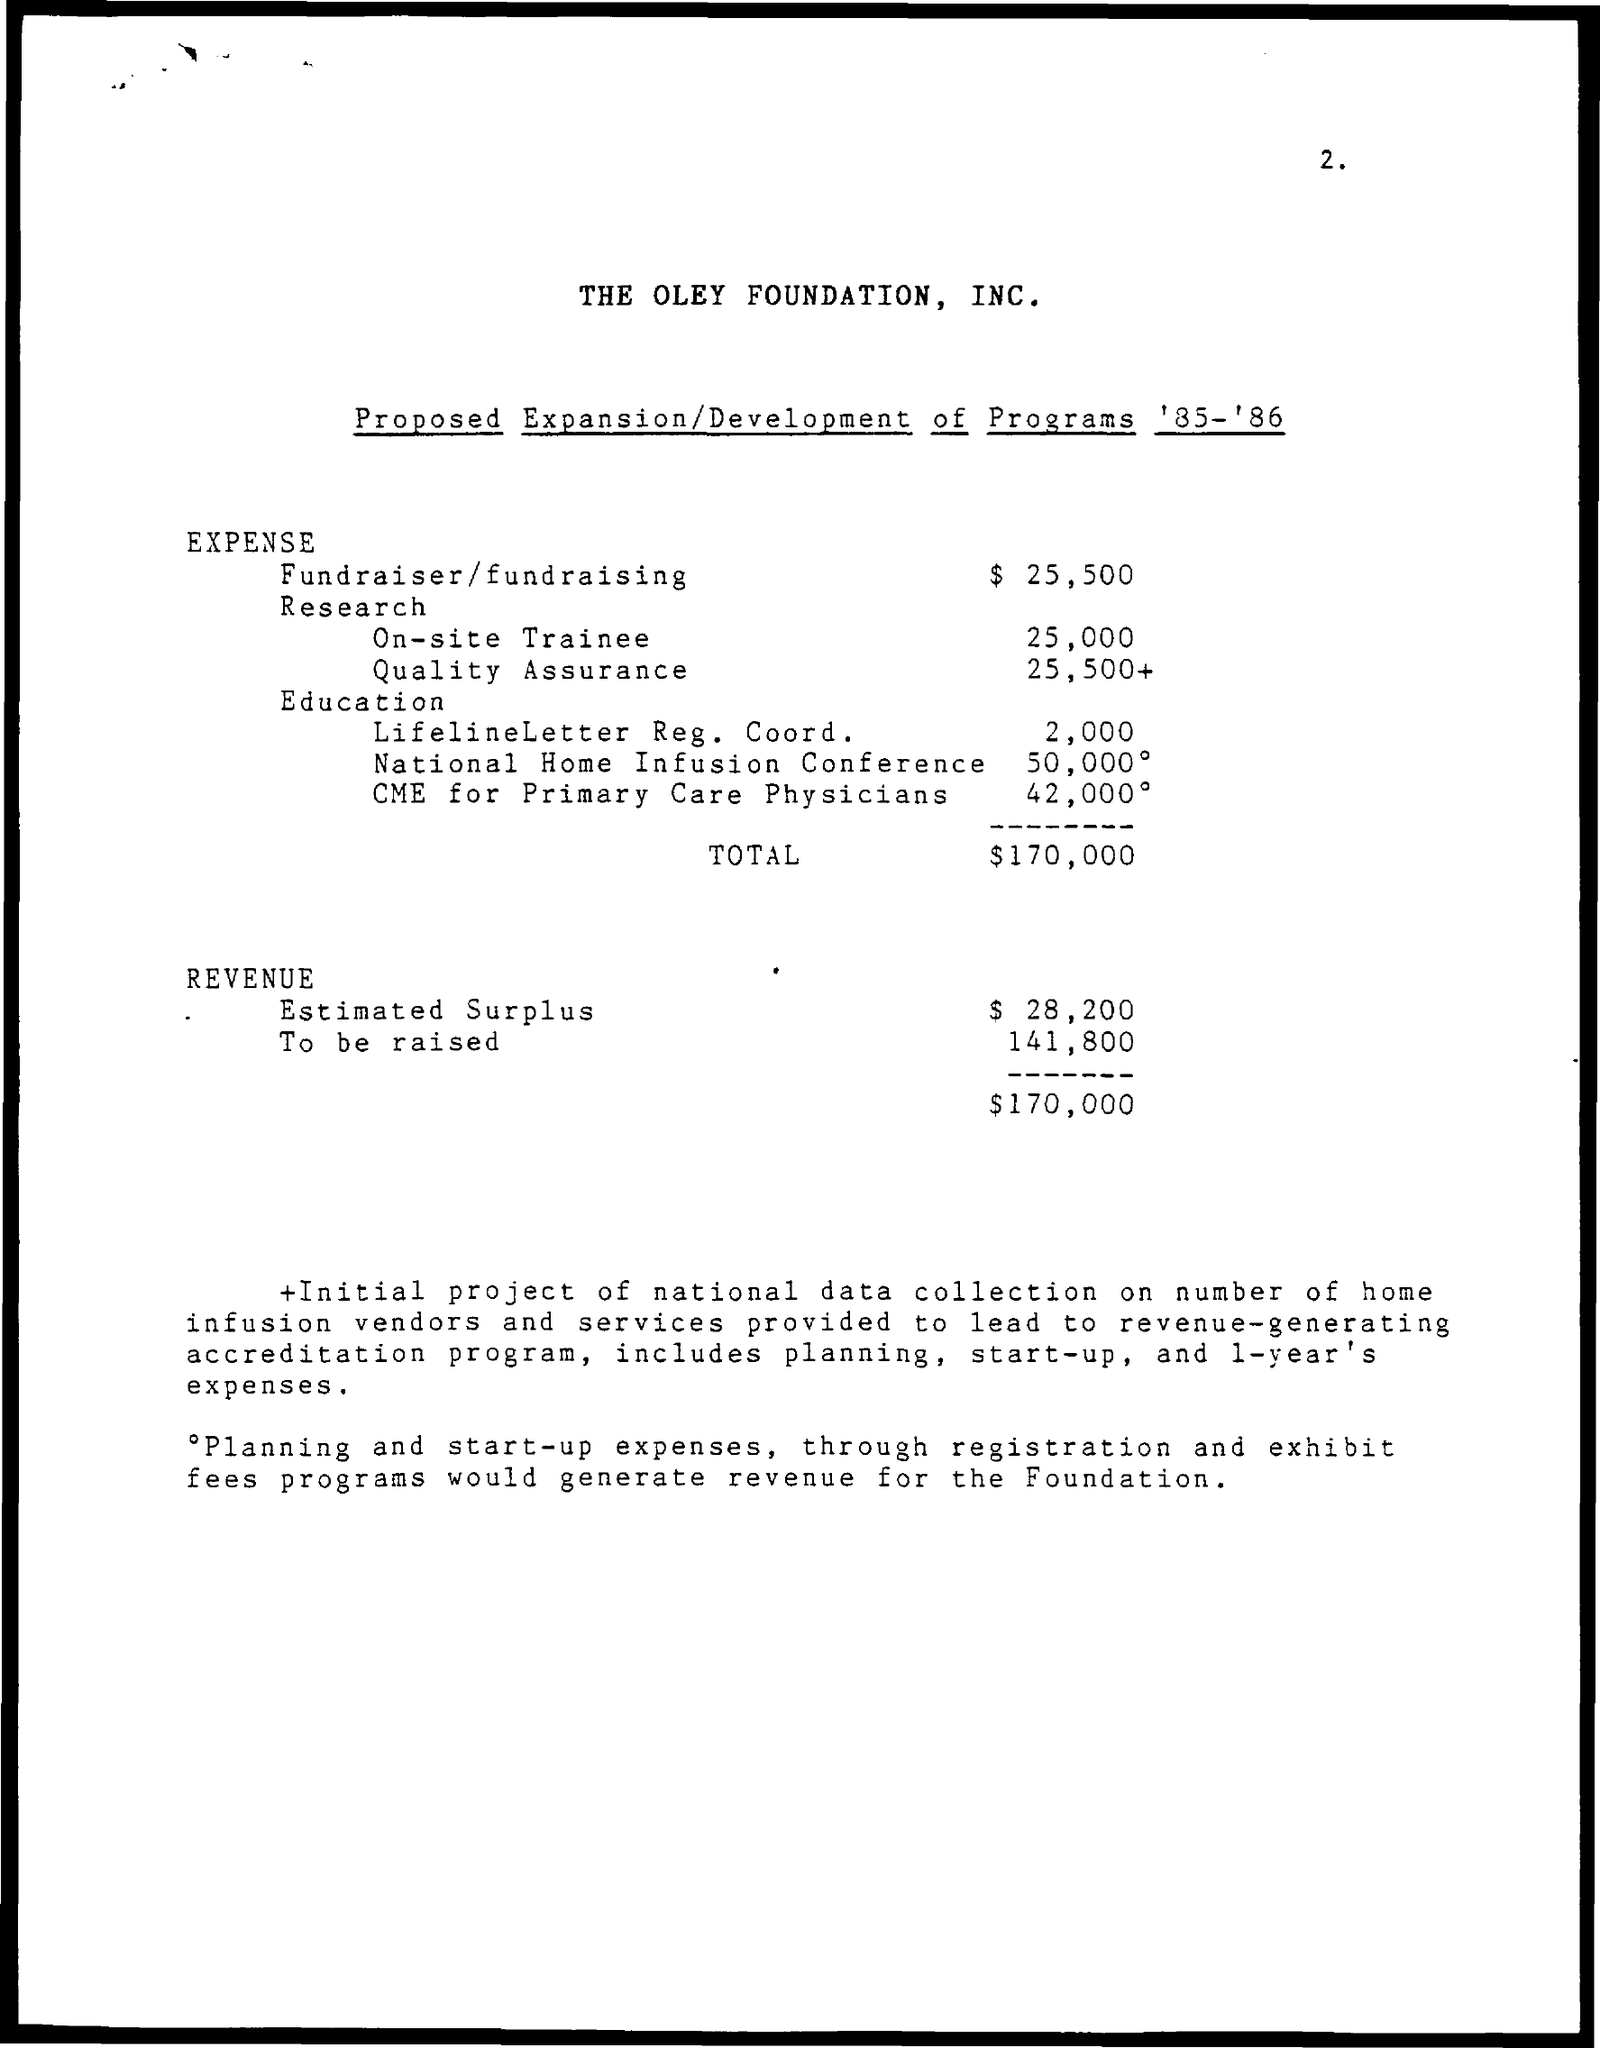What is the name of the Foundation?
Keep it short and to the point. The Oley Foundation, Inc. 